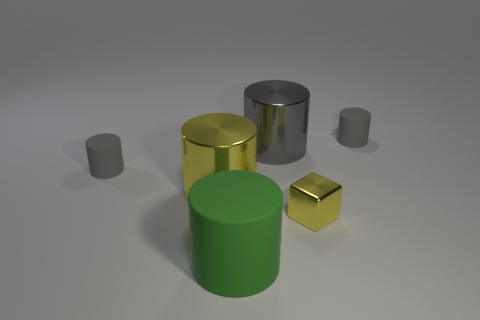Subtract all green blocks. How many gray cylinders are left? 3 Subtract all big cylinders. How many cylinders are left? 2 Subtract all yellow cylinders. How many cylinders are left? 4 Subtract 2 cylinders. How many cylinders are left? 3 Subtract all yellow cylinders. Subtract all green spheres. How many cylinders are left? 4 Add 2 small yellow shiny things. How many objects exist? 8 Subtract all cylinders. How many objects are left? 1 Add 3 green cylinders. How many green cylinders are left? 4 Add 1 tiny rubber cylinders. How many tiny rubber cylinders exist? 3 Subtract 0 gray blocks. How many objects are left? 6 